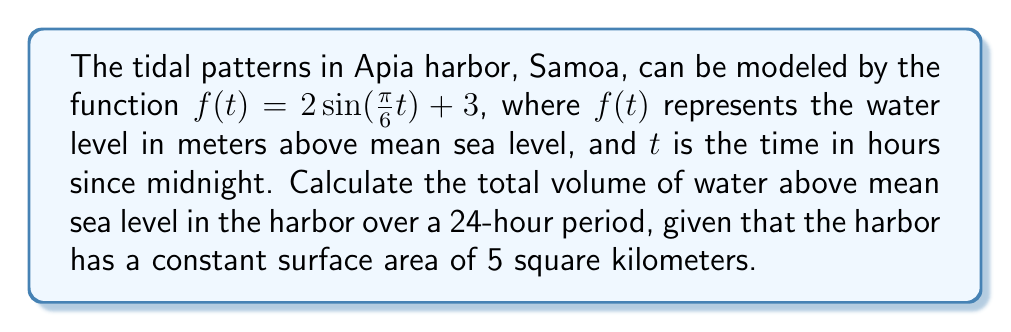Teach me how to tackle this problem. To solve this problem, we need to follow these steps:

1) First, we need to find the area under the curve $f(t) = 2\sin(\frac{\pi}{6}t) + 3$ over a 24-hour period. This can be done using a definite integral.

2) The definite integral will give us the average height of water above mean sea level over the 24-hour period.

3) We'll then multiply this average height by the surface area of the harbor to get the volume.

Let's proceed step by step:

1) The area under the curve is given by the definite integral:

   $$A = \int_0^{24} (2\sin(\frac{\pi}{6}t) + 3) dt$$

2) Let's solve this integral:
   
   $$A = [-\frac{12}{\pi}\cos(\frac{\pi}{6}t) + 3t]_0^{24}$$
   
   $$A = [-\frac{12}{\pi}\cos(4\pi) + 3(24)] - [-\frac{12}{\pi}\cos(0) + 3(0)]$$
   
   $$A = [-\frac{12}{\pi} + 72] - [-\frac{12}{\pi}]$$
   
   $$A = 72$$

3) This means that over 24 hours, the average water level above mean sea level is:
   
   $$\text{Average height} = \frac{72}{24} = 3 \text{ meters}$$

4) Now, to find the volume, we multiply this average height by the surface area:
   
   $$\text{Volume} = 3 \text{ m} \times 5 \text{ km}^2 = 3 \text{ m} \times 5,000,000 \text{ m}^2 = 15,000,000 \text{ m}^3$$

Therefore, the total volume of water above mean sea level in the harbor over a 24-hour period is 15 million cubic meters.
Answer: 15,000,000 cubic meters 